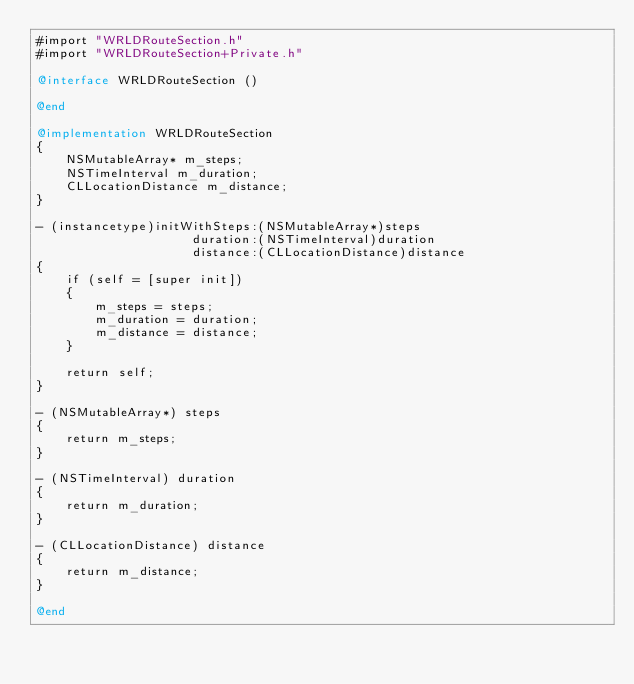Convert code to text. <code><loc_0><loc_0><loc_500><loc_500><_ObjectiveC_>#import "WRLDRouteSection.h"
#import "WRLDRouteSection+Private.h"

@interface WRLDRouteSection ()

@end

@implementation WRLDRouteSection
{
    NSMutableArray* m_steps;
    NSTimeInterval m_duration;
    CLLocationDistance m_distance;
}

- (instancetype)initWithSteps:(NSMutableArray*)steps
                     duration:(NSTimeInterval)duration
                     distance:(CLLocationDistance)distance
{
    if (self = [super init])
    {
        m_steps = steps;
        m_duration = duration;
        m_distance = distance;
    }

    return self;
}

- (NSMutableArray*) steps
{
    return m_steps;
}

- (NSTimeInterval) duration
{
    return m_duration;
}

- (CLLocationDistance) distance
{
    return m_distance;
}

@end
</code> 